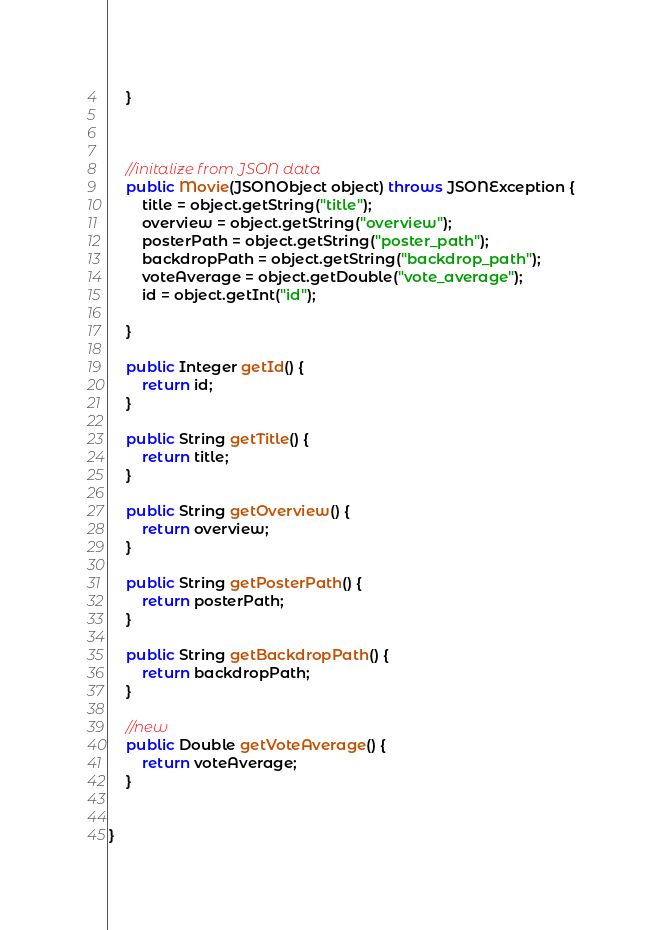<code> <loc_0><loc_0><loc_500><loc_500><_Java_>    }



    //initalize from JSON data
    public Movie(JSONObject object) throws JSONException {
        title = object.getString("title");
        overview = object.getString("overview");
        posterPath = object.getString("poster_path");
        backdropPath = object.getString("backdrop_path");
        voteAverage = object.getDouble("vote_average");
        id = object.getInt("id");

    }

    public Integer getId() {
        return id;
    }

    public String getTitle() {
        return title;
    }

    public String getOverview() {
        return overview;
    }

    public String getPosterPath() {
        return posterPath;
    }

    public String getBackdropPath() {
        return backdropPath;
    }

    //new
    public Double getVoteAverage() {
        return voteAverage;
    }


}

</code> 